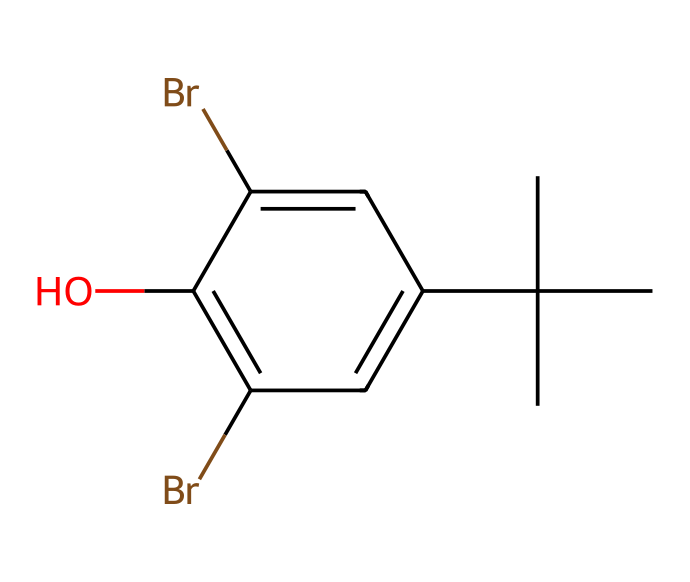How many bromine atoms are in this compound? By examining the SMILES representation, we find 'Br' appears twice, indicating there are two bromine atoms present in the chemical structure.
Answer: two What type of functional group does the chemical contain? The presence of the 'O' in the SMILES indicates the presence of a hydroxyl group (-OH), which identifies this compound as an alcohol.
Answer: hydroxyl group How many carbon atoms are in the chemical structure? In the SMILES, 'C' appears a total of six times, indicating there are six carbon atoms in the structure.
Answer: six What is the role of bromine in this material? Bromine typically acts as a flame retardant in adhesive formulations, thus enhancing the safety profile of orthodontic adhesives.
Answer: flame retardant Is this compound likely to be aromatic? The chemical structure contains a benzene-like ring indicated by 'c' in the SMILES, confirming that the compound is indeed aromatic due to the alternating double bonds and cyclic structure.
Answer: aromatic How does the presence of bromine affect the molecular reactivity? Bromine's electron-withdrawing nature can influence the reactivity of the compound, making it more susceptible to nucleophilic attack, which is crucial in adhesive bonding processes.
Answer: electron-withdrawing What is the molecular formula derived from the SMILES? By counting the atoms represented, the molecular formula can be derived as C6H8Br2O, taking into account the carbons (C), hydrogens (H), bromines (Br), and oxygen (O).
Answer: C6H8Br2O 